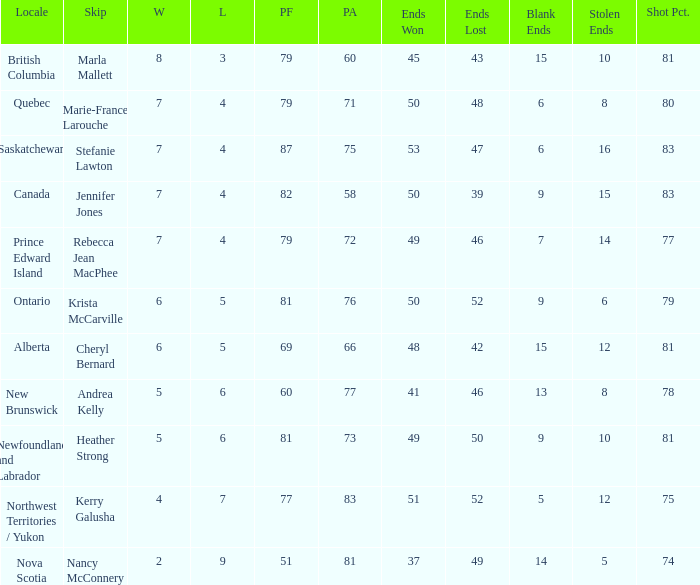What is the total of blank ends at Prince Edward Island? 7.0. 